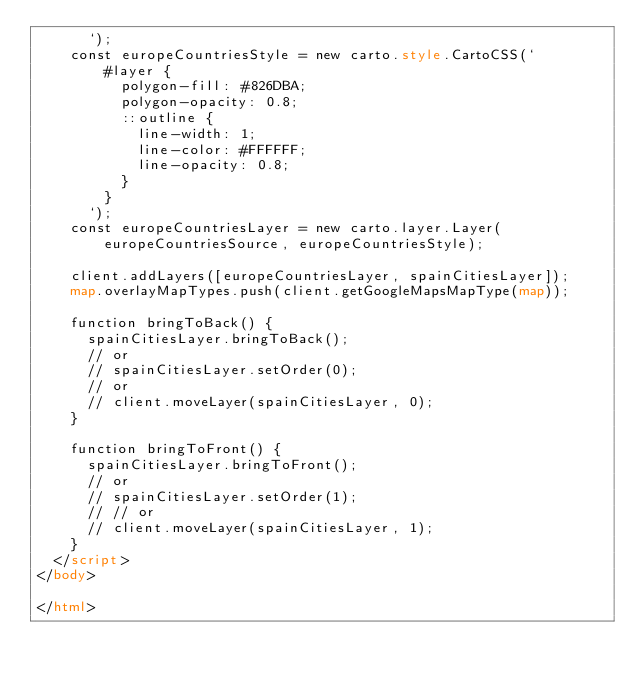Convert code to text. <code><loc_0><loc_0><loc_500><loc_500><_HTML_>      `);
    const europeCountriesStyle = new carto.style.CartoCSS(`
        #layer {
          polygon-fill: #826DBA;
          polygon-opacity: 0.8;
          ::outline {
            line-width: 1;
            line-color: #FFFFFF;
            line-opacity: 0.8;
          }
        }
      `);
    const europeCountriesLayer = new carto.layer.Layer(europeCountriesSource, europeCountriesStyle);

    client.addLayers([europeCountriesLayer, spainCitiesLayer]);
    map.overlayMapTypes.push(client.getGoogleMapsMapType(map));

    function bringToBack() {
      spainCitiesLayer.bringToBack();
      // or
      // spainCitiesLayer.setOrder(0);
      // or
      // client.moveLayer(spainCitiesLayer, 0);
    }

    function bringToFront() {
      spainCitiesLayer.bringToFront();
      // or
      // spainCitiesLayer.setOrder(1);
      // // or
      // client.moveLayer(spainCitiesLayer, 1);
    }
  </script>
</body>

</html></code> 